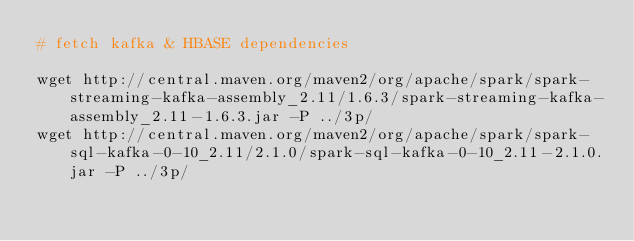Convert code to text. <code><loc_0><loc_0><loc_500><loc_500><_Bash_># fetch kafka & HBASE dependencies 

wget http://central.maven.org/maven2/org/apache/spark/spark-streaming-kafka-assembly_2.11/1.6.3/spark-streaming-kafka-assembly_2.11-1.6.3.jar -P ../3p/  
wget http://central.maven.org/maven2/org/apache/spark/spark-sql-kafka-0-10_2.11/2.1.0/spark-sql-kafka-0-10_2.11-2.1.0.jar -P ../3p/  

</code> 